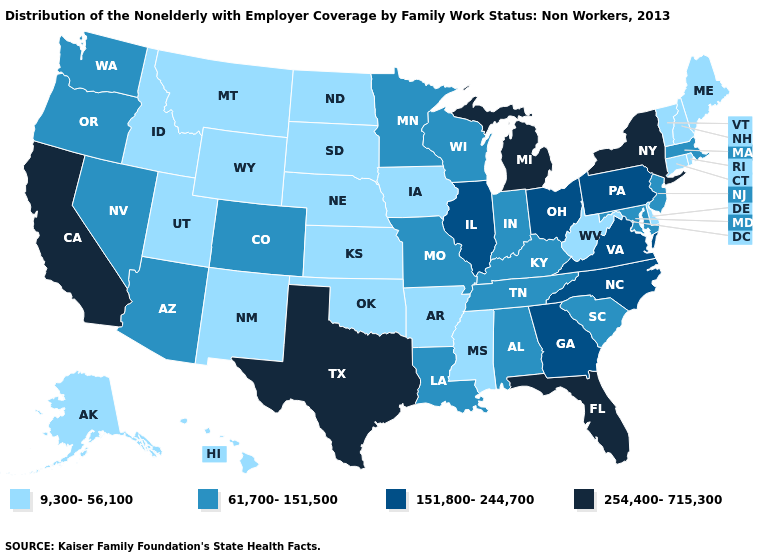What is the highest value in the Northeast ?
Keep it brief. 254,400-715,300. Name the states that have a value in the range 61,700-151,500?
Answer briefly. Alabama, Arizona, Colorado, Indiana, Kentucky, Louisiana, Maryland, Massachusetts, Minnesota, Missouri, Nevada, New Jersey, Oregon, South Carolina, Tennessee, Washington, Wisconsin. Name the states that have a value in the range 254,400-715,300?
Give a very brief answer. California, Florida, Michigan, New York, Texas. Among the states that border Missouri , which have the lowest value?
Be succinct. Arkansas, Iowa, Kansas, Nebraska, Oklahoma. Does the map have missing data?
Give a very brief answer. No. Does Missouri have a lower value than South Carolina?
Answer briefly. No. How many symbols are there in the legend?
Give a very brief answer. 4. Does the map have missing data?
Short answer required. No. Which states have the lowest value in the MidWest?
Concise answer only. Iowa, Kansas, Nebraska, North Dakota, South Dakota. Name the states that have a value in the range 254,400-715,300?
Concise answer only. California, Florida, Michigan, New York, Texas. Name the states that have a value in the range 9,300-56,100?
Write a very short answer. Alaska, Arkansas, Connecticut, Delaware, Hawaii, Idaho, Iowa, Kansas, Maine, Mississippi, Montana, Nebraska, New Hampshire, New Mexico, North Dakota, Oklahoma, Rhode Island, South Dakota, Utah, Vermont, West Virginia, Wyoming. What is the highest value in the USA?
Keep it brief. 254,400-715,300. Name the states that have a value in the range 254,400-715,300?
Answer briefly. California, Florida, Michigan, New York, Texas. What is the lowest value in the USA?
Quick response, please. 9,300-56,100. What is the lowest value in states that border Washington?
Quick response, please. 9,300-56,100. 